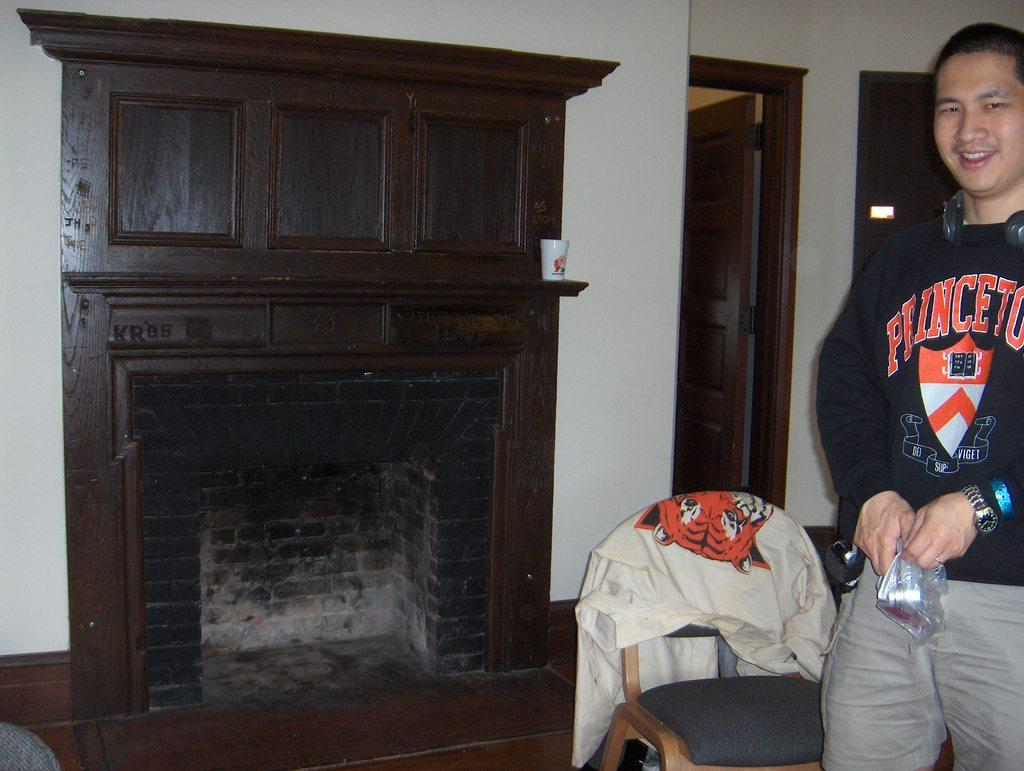<image>
Share a concise interpretation of the image provided. A man in a Princeton sweatshirt stands next to a fireplace. 